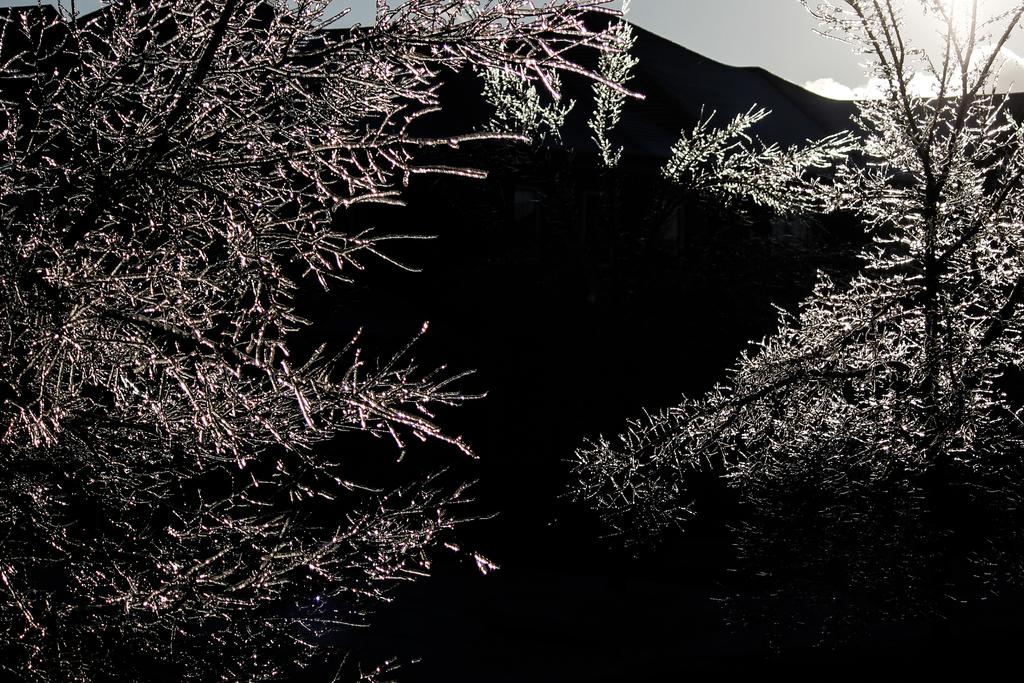What type of vegetation can be seen in the image? There are trees in the image. What geographical features are present in the image? There are hills in the image. What can be seen in the sky in the image? Clouds are visible in the sky in the image. What type of food is hanging from the trees in the image? There is no food hanging from the trees in the image; only trees and hills are present. 